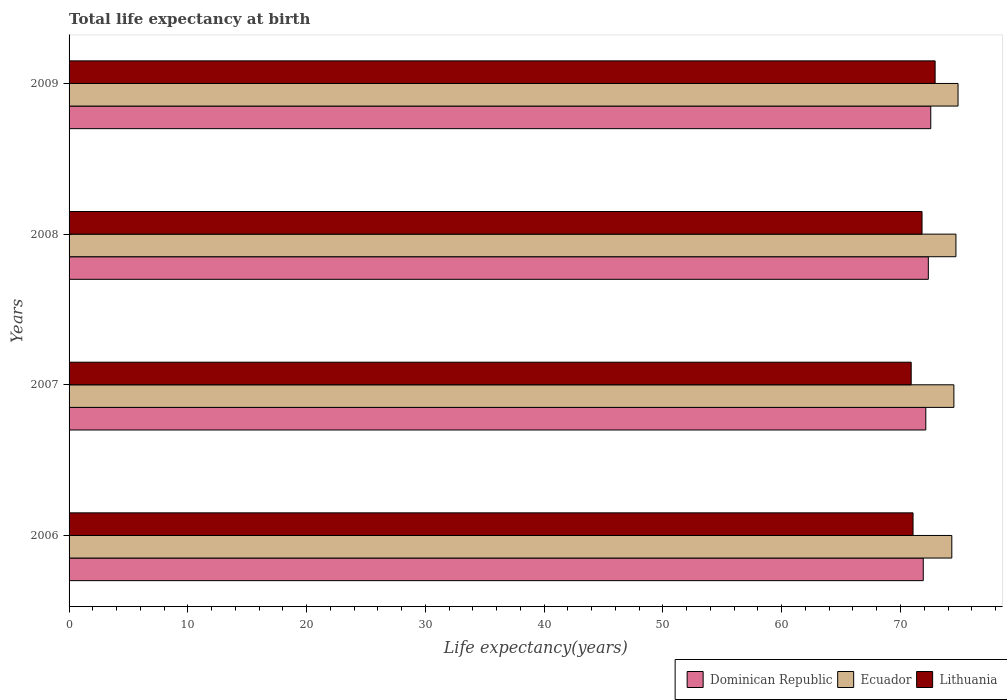Are the number of bars on each tick of the Y-axis equal?
Keep it short and to the point. Yes. What is the label of the 2nd group of bars from the top?
Provide a succinct answer. 2008. What is the life expectancy at birth in in Lithuania in 2006?
Make the answer very short. 71.06. Across all years, what is the maximum life expectancy at birth in in Dominican Republic?
Provide a succinct answer. 72.55. Across all years, what is the minimum life expectancy at birth in in Lithuania?
Make the answer very short. 70.9. In which year was the life expectancy at birth in in Ecuador maximum?
Keep it short and to the point. 2009. What is the total life expectancy at birth in in Ecuador in the graph?
Give a very brief answer. 298.33. What is the difference between the life expectancy at birth in in Dominican Republic in 2007 and that in 2008?
Provide a succinct answer. -0.21. What is the difference between the life expectancy at birth in in Ecuador in 2006 and the life expectancy at birth in in Dominican Republic in 2008?
Make the answer very short. 1.98. What is the average life expectancy at birth in in Dominican Republic per year?
Give a very brief answer. 72.23. In the year 2006, what is the difference between the life expectancy at birth in in Ecuador and life expectancy at birth in in Lithuania?
Provide a short and direct response. 3.26. In how many years, is the life expectancy at birth in in Ecuador greater than 26 years?
Offer a terse response. 4. What is the ratio of the life expectancy at birth in in Dominican Republic in 2007 to that in 2008?
Ensure brevity in your answer.  1. Is the life expectancy at birth in in Dominican Republic in 2008 less than that in 2009?
Make the answer very short. Yes. Is the difference between the life expectancy at birth in in Ecuador in 2007 and 2008 greater than the difference between the life expectancy at birth in in Lithuania in 2007 and 2008?
Offer a terse response. Yes. What is the difference between the highest and the second highest life expectancy at birth in in Ecuador?
Your answer should be compact. 0.18. What is the difference between the highest and the lowest life expectancy at birth in in Ecuador?
Your answer should be very brief. 0.52. What does the 2nd bar from the top in 2006 represents?
Offer a very short reply. Ecuador. What does the 2nd bar from the bottom in 2007 represents?
Your response must be concise. Ecuador. How many bars are there?
Your answer should be very brief. 12. Are all the bars in the graph horizontal?
Ensure brevity in your answer.  Yes. Does the graph contain grids?
Make the answer very short. No. How are the legend labels stacked?
Your answer should be very brief. Horizontal. What is the title of the graph?
Ensure brevity in your answer.  Total life expectancy at birth. What is the label or title of the X-axis?
Provide a succinct answer. Life expectancy(years). What is the label or title of the Y-axis?
Keep it short and to the point. Years. What is the Life expectancy(years) in Dominican Republic in 2006?
Make the answer very short. 71.92. What is the Life expectancy(years) in Ecuador in 2006?
Provide a short and direct response. 74.32. What is the Life expectancy(years) in Lithuania in 2006?
Your response must be concise. 71.06. What is the Life expectancy(years) of Dominican Republic in 2007?
Your answer should be very brief. 72.13. What is the Life expectancy(years) of Ecuador in 2007?
Give a very brief answer. 74.5. What is the Life expectancy(years) of Lithuania in 2007?
Provide a short and direct response. 70.9. What is the Life expectancy(years) of Dominican Republic in 2008?
Give a very brief answer. 72.34. What is the Life expectancy(years) in Ecuador in 2008?
Make the answer very short. 74.67. What is the Life expectancy(years) in Lithuania in 2008?
Provide a short and direct response. 71.81. What is the Life expectancy(years) of Dominican Republic in 2009?
Provide a short and direct response. 72.55. What is the Life expectancy(years) in Ecuador in 2009?
Ensure brevity in your answer.  74.84. What is the Life expectancy(years) of Lithuania in 2009?
Give a very brief answer. 72.91. Across all years, what is the maximum Life expectancy(years) in Dominican Republic?
Your response must be concise. 72.55. Across all years, what is the maximum Life expectancy(years) in Ecuador?
Make the answer very short. 74.84. Across all years, what is the maximum Life expectancy(years) of Lithuania?
Offer a very short reply. 72.91. Across all years, what is the minimum Life expectancy(years) in Dominican Republic?
Make the answer very short. 71.92. Across all years, what is the minimum Life expectancy(years) of Ecuador?
Give a very brief answer. 74.32. Across all years, what is the minimum Life expectancy(years) in Lithuania?
Your answer should be very brief. 70.9. What is the total Life expectancy(years) in Dominican Republic in the graph?
Provide a short and direct response. 288.94. What is the total Life expectancy(years) in Ecuador in the graph?
Give a very brief answer. 298.33. What is the total Life expectancy(years) in Lithuania in the graph?
Keep it short and to the point. 286.68. What is the difference between the Life expectancy(years) in Dominican Republic in 2006 and that in 2007?
Give a very brief answer. -0.21. What is the difference between the Life expectancy(years) of Ecuador in 2006 and that in 2007?
Your answer should be compact. -0.17. What is the difference between the Life expectancy(years) of Lithuania in 2006 and that in 2007?
Provide a short and direct response. 0.16. What is the difference between the Life expectancy(years) in Dominican Republic in 2006 and that in 2008?
Your response must be concise. -0.43. What is the difference between the Life expectancy(years) of Ecuador in 2006 and that in 2008?
Offer a very short reply. -0.35. What is the difference between the Life expectancy(years) of Lithuania in 2006 and that in 2008?
Offer a terse response. -0.76. What is the difference between the Life expectancy(years) in Dominican Republic in 2006 and that in 2009?
Provide a short and direct response. -0.63. What is the difference between the Life expectancy(years) in Ecuador in 2006 and that in 2009?
Provide a short and direct response. -0.52. What is the difference between the Life expectancy(years) in Lithuania in 2006 and that in 2009?
Keep it short and to the point. -1.86. What is the difference between the Life expectancy(years) of Dominican Republic in 2007 and that in 2008?
Your answer should be compact. -0.21. What is the difference between the Life expectancy(years) in Ecuador in 2007 and that in 2008?
Give a very brief answer. -0.17. What is the difference between the Life expectancy(years) in Lithuania in 2007 and that in 2008?
Keep it short and to the point. -0.91. What is the difference between the Life expectancy(years) of Dominican Republic in 2007 and that in 2009?
Make the answer very short. -0.42. What is the difference between the Life expectancy(years) of Ecuador in 2007 and that in 2009?
Your answer should be very brief. -0.35. What is the difference between the Life expectancy(years) of Lithuania in 2007 and that in 2009?
Provide a succinct answer. -2.01. What is the difference between the Life expectancy(years) of Dominican Republic in 2008 and that in 2009?
Your answer should be compact. -0.21. What is the difference between the Life expectancy(years) in Ecuador in 2008 and that in 2009?
Offer a very short reply. -0.18. What is the difference between the Life expectancy(years) of Lithuania in 2008 and that in 2009?
Your answer should be very brief. -1.1. What is the difference between the Life expectancy(years) in Dominican Republic in 2006 and the Life expectancy(years) in Ecuador in 2007?
Offer a very short reply. -2.58. What is the difference between the Life expectancy(years) of Dominican Republic in 2006 and the Life expectancy(years) of Lithuania in 2007?
Your answer should be compact. 1.02. What is the difference between the Life expectancy(years) in Ecuador in 2006 and the Life expectancy(years) in Lithuania in 2007?
Offer a terse response. 3.42. What is the difference between the Life expectancy(years) in Dominican Republic in 2006 and the Life expectancy(years) in Ecuador in 2008?
Offer a very short reply. -2.75. What is the difference between the Life expectancy(years) of Dominican Republic in 2006 and the Life expectancy(years) of Lithuania in 2008?
Keep it short and to the point. 0.1. What is the difference between the Life expectancy(years) in Ecuador in 2006 and the Life expectancy(years) in Lithuania in 2008?
Offer a terse response. 2.51. What is the difference between the Life expectancy(years) in Dominican Republic in 2006 and the Life expectancy(years) in Ecuador in 2009?
Offer a very short reply. -2.93. What is the difference between the Life expectancy(years) in Dominican Republic in 2006 and the Life expectancy(years) in Lithuania in 2009?
Make the answer very short. -1. What is the difference between the Life expectancy(years) in Ecuador in 2006 and the Life expectancy(years) in Lithuania in 2009?
Give a very brief answer. 1.41. What is the difference between the Life expectancy(years) of Dominican Republic in 2007 and the Life expectancy(years) of Ecuador in 2008?
Ensure brevity in your answer.  -2.54. What is the difference between the Life expectancy(years) of Dominican Republic in 2007 and the Life expectancy(years) of Lithuania in 2008?
Your response must be concise. 0.32. What is the difference between the Life expectancy(years) of Ecuador in 2007 and the Life expectancy(years) of Lithuania in 2008?
Keep it short and to the point. 2.68. What is the difference between the Life expectancy(years) in Dominican Republic in 2007 and the Life expectancy(years) in Ecuador in 2009?
Offer a very short reply. -2.71. What is the difference between the Life expectancy(years) of Dominican Republic in 2007 and the Life expectancy(years) of Lithuania in 2009?
Keep it short and to the point. -0.78. What is the difference between the Life expectancy(years) in Ecuador in 2007 and the Life expectancy(years) in Lithuania in 2009?
Your answer should be very brief. 1.58. What is the difference between the Life expectancy(years) of Dominican Republic in 2008 and the Life expectancy(years) of Ecuador in 2009?
Give a very brief answer. -2.5. What is the difference between the Life expectancy(years) of Dominican Republic in 2008 and the Life expectancy(years) of Lithuania in 2009?
Offer a terse response. -0.57. What is the difference between the Life expectancy(years) of Ecuador in 2008 and the Life expectancy(years) of Lithuania in 2009?
Your response must be concise. 1.75. What is the average Life expectancy(years) in Dominican Republic per year?
Ensure brevity in your answer.  72.23. What is the average Life expectancy(years) in Ecuador per year?
Provide a short and direct response. 74.58. What is the average Life expectancy(years) in Lithuania per year?
Your answer should be very brief. 71.67. In the year 2006, what is the difference between the Life expectancy(years) of Dominican Republic and Life expectancy(years) of Ecuador?
Provide a short and direct response. -2.4. In the year 2006, what is the difference between the Life expectancy(years) in Dominican Republic and Life expectancy(years) in Lithuania?
Give a very brief answer. 0.86. In the year 2006, what is the difference between the Life expectancy(years) of Ecuador and Life expectancy(years) of Lithuania?
Your answer should be compact. 3.26. In the year 2007, what is the difference between the Life expectancy(years) of Dominican Republic and Life expectancy(years) of Ecuador?
Offer a terse response. -2.36. In the year 2007, what is the difference between the Life expectancy(years) of Dominican Republic and Life expectancy(years) of Lithuania?
Give a very brief answer. 1.23. In the year 2007, what is the difference between the Life expectancy(years) in Ecuador and Life expectancy(years) in Lithuania?
Give a very brief answer. 3.6. In the year 2008, what is the difference between the Life expectancy(years) of Dominican Republic and Life expectancy(years) of Ecuador?
Provide a short and direct response. -2.33. In the year 2008, what is the difference between the Life expectancy(years) of Dominican Republic and Life expectancy(years) of Lithuania?
Offer a very short reply. 0.53. In the year 2008, what is the difference between the Life expectancy(years) in Ecuador and Life expectancy(years) in Lithuania?
Provide a succinct answer. 2.86. In the year 2009, what is the difference between the Life expectancy(years) in Dominican Republic and Life expectancy(years) in Ecuador?
Provide a short and direct response. -2.3. In the year 2009, what is the difference between the Life expectancy(years) in Dominican Republic and Life expectancy(years) in Lithuania?
Give a very brief answer. -0.37. In the year 2009, what is the difference between the Life expectancy(years) in Ecuador and Life expectancy(years) in Lithuania?
Ensure brevity in your answer.  1.93. What is the ratio of the Life expectancy(years) of Dominican Republic in 2006 to that in 2007?
Your answer should be very brief. 1. What is the ratio of the Life expectancy(years) of Ecuador in 2006 to that in 2007?
Your response must be concise. 1. What is the ratio of the Life expectancy(years) in Dominican Republic in 2006 to that in 2008?
Provide a short and direct response. 0.99. What is the ratio of the Life expectancy(years) of Dominican Republic in 2006 to that in 2009?
Your answer should be compact. 0.99. What is the ratio of the Life expectancy(years) in Ecuador in 2006 to that in 2009?
Provide a short and direct response. 0.99. What is the ratio of the Life expectancy(years) in Lithuania in 2006 to that in 2009?
Provide a succinct answer. 0.97. What is the ratio of the Life expectancy(years) of Ecuador in 2007 to that in 2008?
Keep it short and to the point. 1. What is the ratio of the Life expectancy(years) of Lithuania in 2007 to that in 2008?
Provide a short and direct response. 0.99. What is the ratio of the Life expectancy(years) in Lithuania in 2007 to that in 2009?
Make the answer very short. 0.97. What is the ratio of the Life expectancy(years) of Dominican Republic in 2008 to that in 2009?
Provide a succinct answer. 1. What is the ratio of the Life expectancy(years) in Ecuador in 2008 to that in 2009?
Ensure brevity in your answer.  1. What is the ratio of the Life expectancy(years) in Lithuania in 2008 to that in 2009?
Keep it short and to the point. 0.98. What is the difference between the highest and the second highest Life expectancy(years) in Dominican Republic?
Give a very brief answer. 0.21. What is the difference between the highest and the second highest Life expectancy(years) in Ecuador?
Ensure brevity in your answer.  0.18. What is the difference between the highest and the second highest Life expectancy(years) in Lithuania?
Your response must be concise. 1.1. What is the difference between the highest and the lowest Life expectancy(years) of Dominican Republic?
Keep it short and to the point. 0.63. What is the difference between the highest and the lowest Life expectancy(years) in Ecuador?
Provide a succinct answer. 0.52. What is the difference between the highest and the lowest Life expectancy(years) in Lithuania?
Keep it short and to the point. 2.01. 